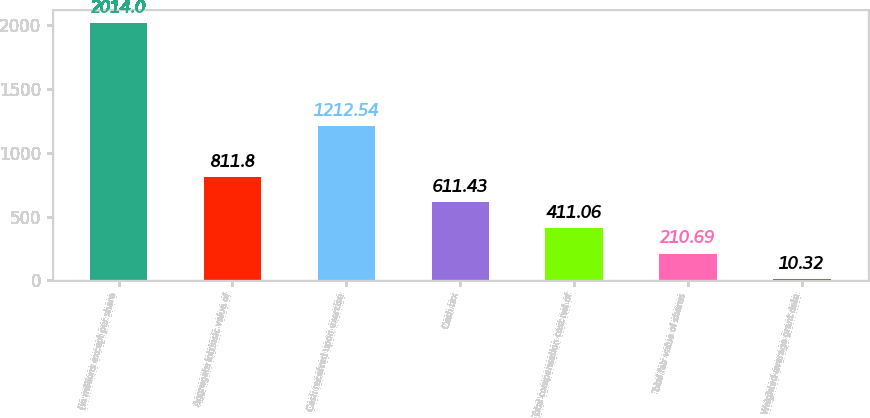Convert chart to OTSL. <chart><loc_0><loc_0><loc_500><loc_500><bar_chart><fcel>(in millions except per share<fcel>Aggregate intrinsic value of<fcel>Cash received upon exercise<fcel>Cash tax<fcel>Total compensation cost net of<fcel>Total fair value of shares<fcel>Weighted-average grant date<nl><fcel>2014<fcel>811.8<fcel>1212.54<fcel>611.43<fcel>411.06<fcel>210.69<fcel>10.32<nl></chart> 